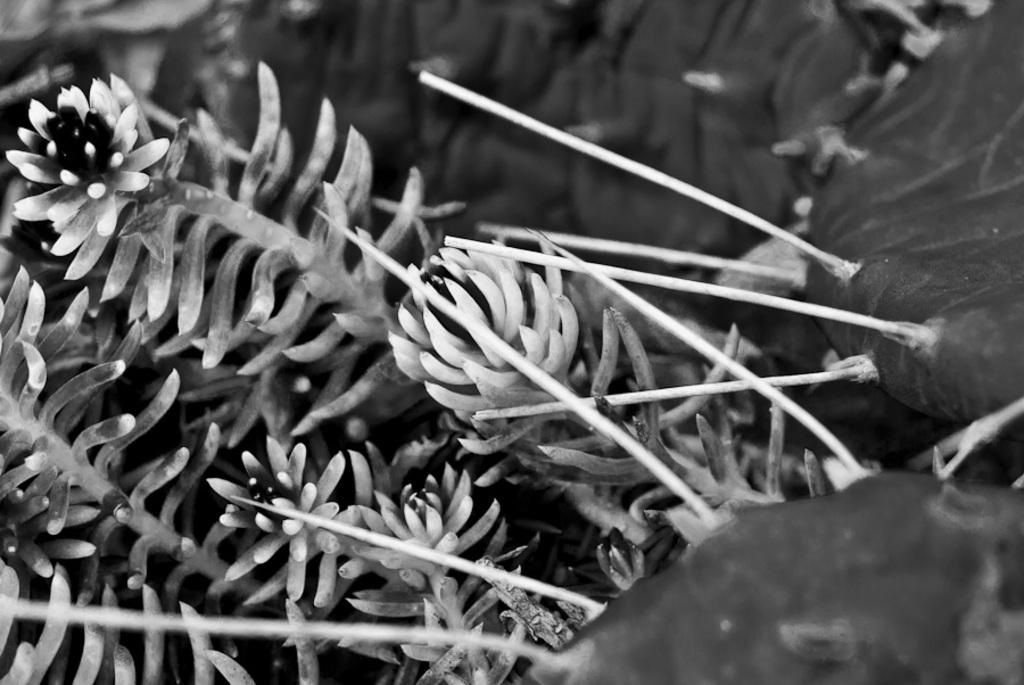What is the color scheme of the image? The image is black and white. What type of natural elements can be seen in the image? There are leaves in the image. How many ducks are visible in the image? There are no ducks present in the image; it only features leaves. What type of vein is visible in the image? There is no vein present in the image, as it only contains leaves. 